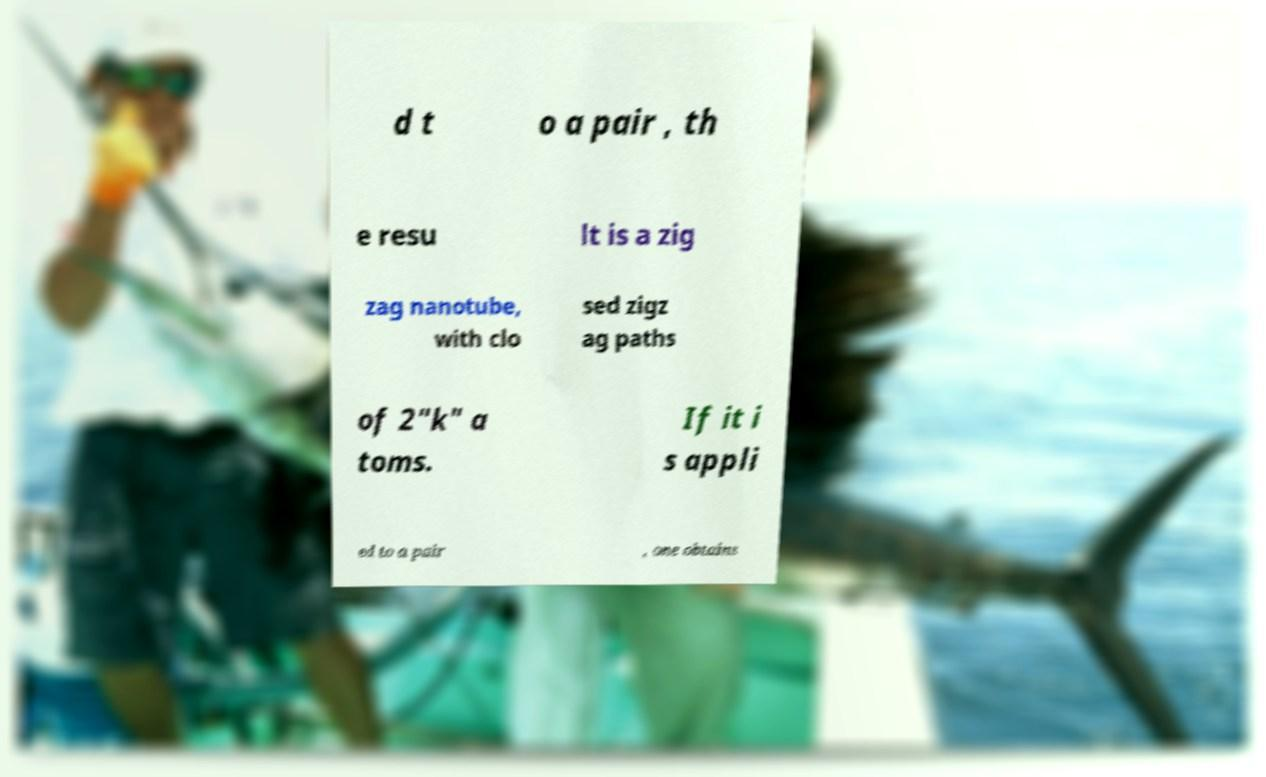Please read and relay the text visible in this image. What does it say? d t o a pair , th e resu lt is a zig zag nanotube, with clo sed zigz ag paths of 2"k" a toms. If it i s appli ed to a pair , one obtains 